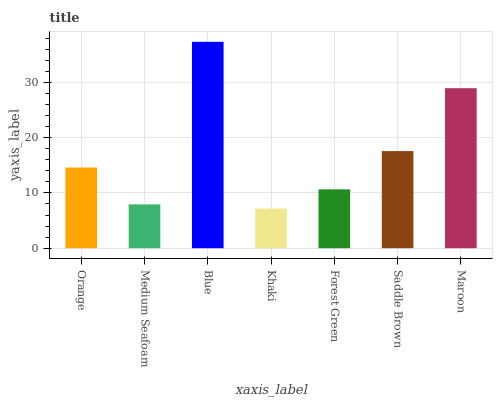Is Medium Seafoam the minimum?
Answer yes or no. No. Is Medium Seafoam the maximum?
Answer yes or no. No. Is Orange greater than Medium Seafoam?
Answer yes or no. Yes. Is Medium Seafoam less than Orange?
Answer yes or no. Yes. Is Medium Seafoam greater than Orange?
Answer yes or no. No. Is Orange less than Medium Seafoam?
Answer yes or no. No. Is Orange the high median?
Answer yes or no. Yes. Is Orange the low median?
Answer yes or no. Yes. Is Medium Seafoam the high median?
Answer yes or no. No. Is Khaki the low median?
Answer yes or no. No. 